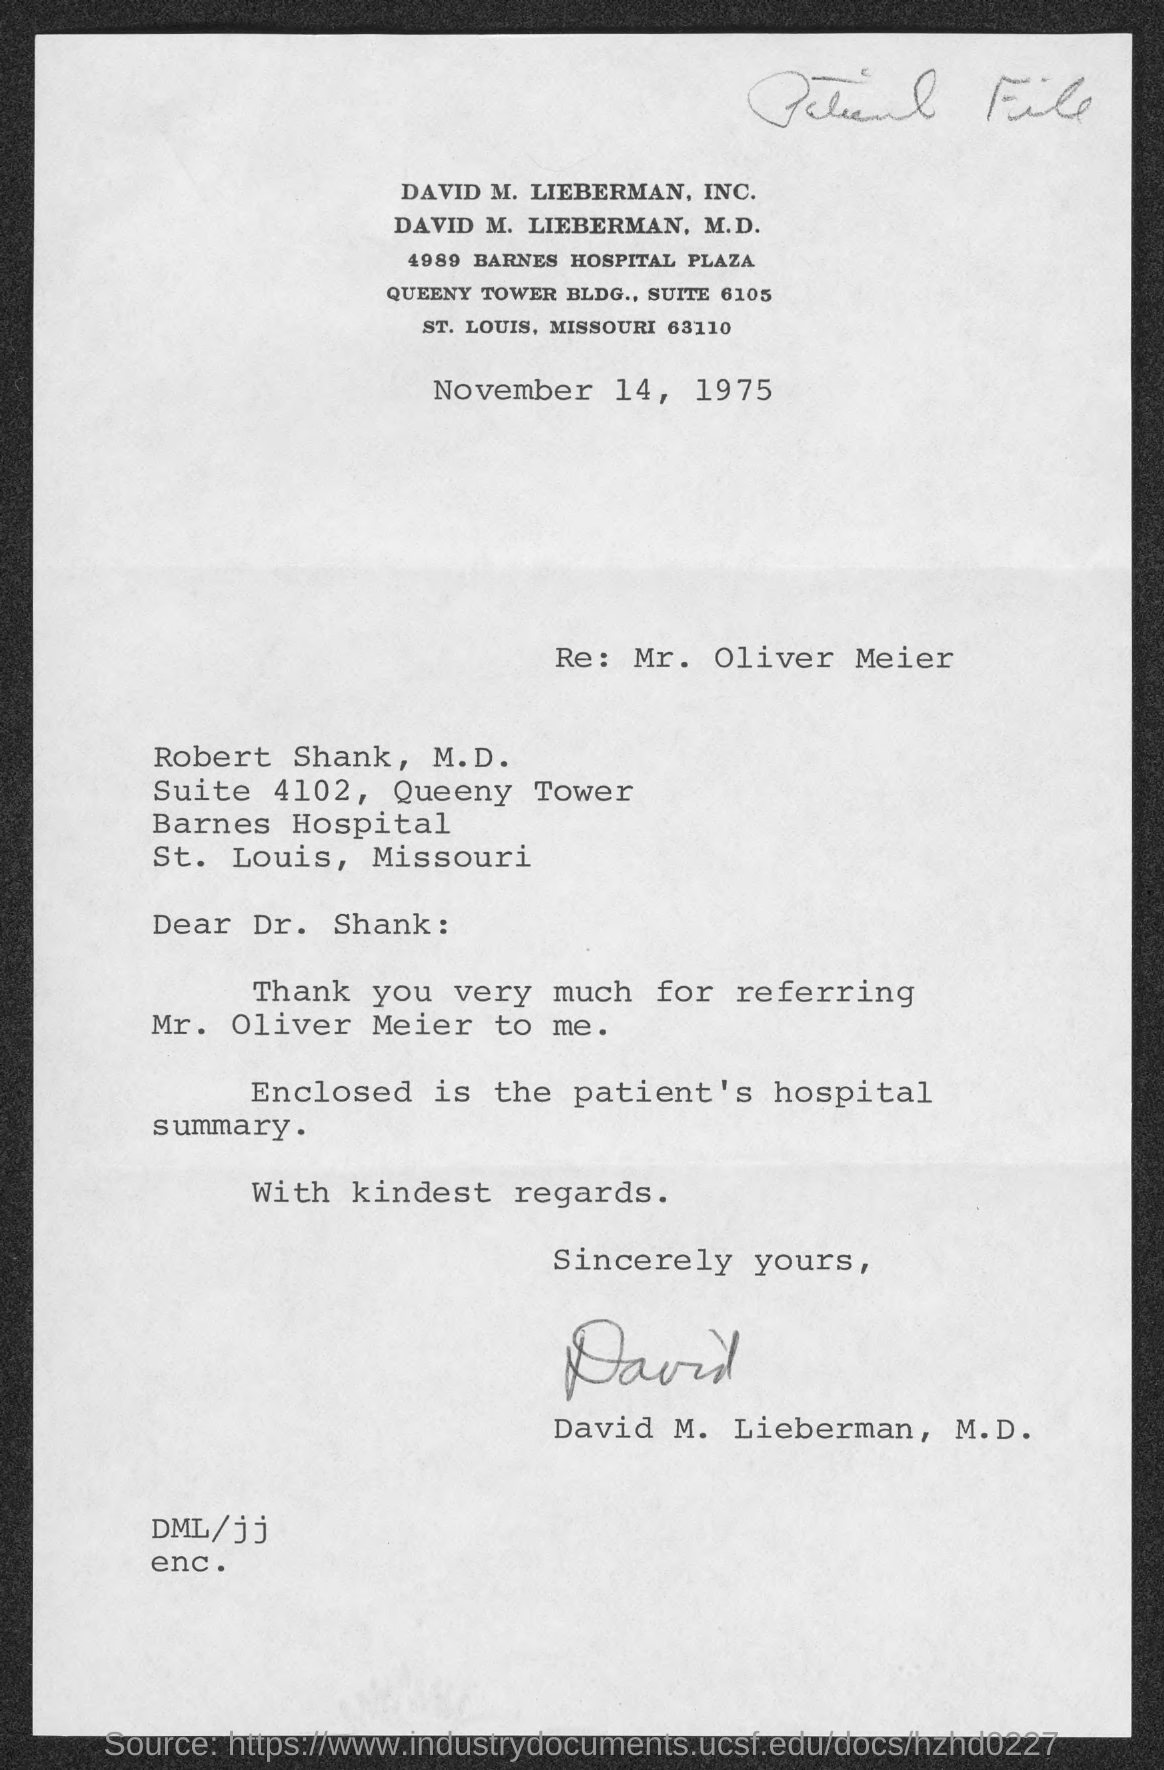Indicate a few pertinent items in this graphic. The date mentioned in the document is November 14, 1975. 